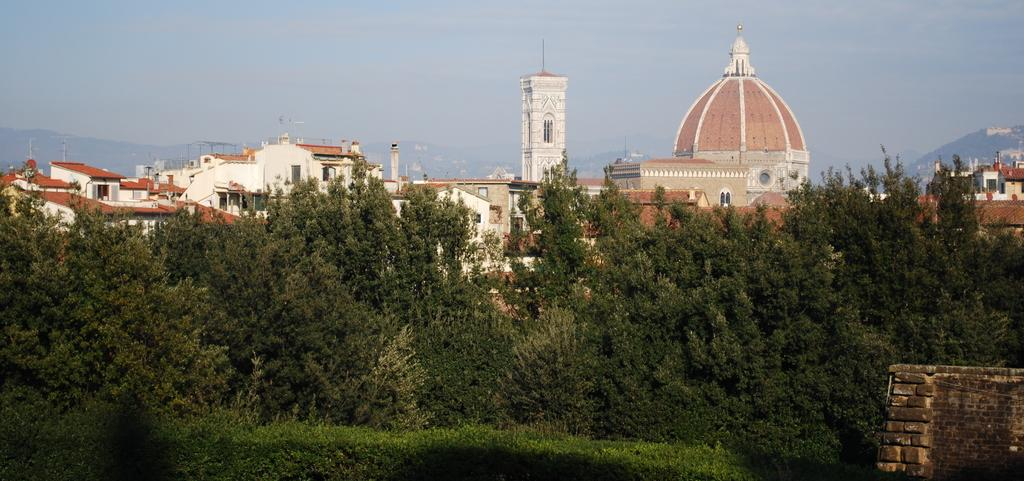What is located at the bottom of the image? There is a tree, grass, and a wall at the bottom of the image. What type of vegetation is present at the bottom of the image? There is grass at the bottom of the image. What can be seen in the background of the image? There are buildings, windows, poles, mountains, and clouds in the sky in the background of the image. Is there an umbrella being used by someone in the image? There is no umbrella present in the image. Can you see a baseball game happening in the background of the image? There is no baseball game visible in the image; it features buildings, windows, poles, mountains, and clouds in the background. 